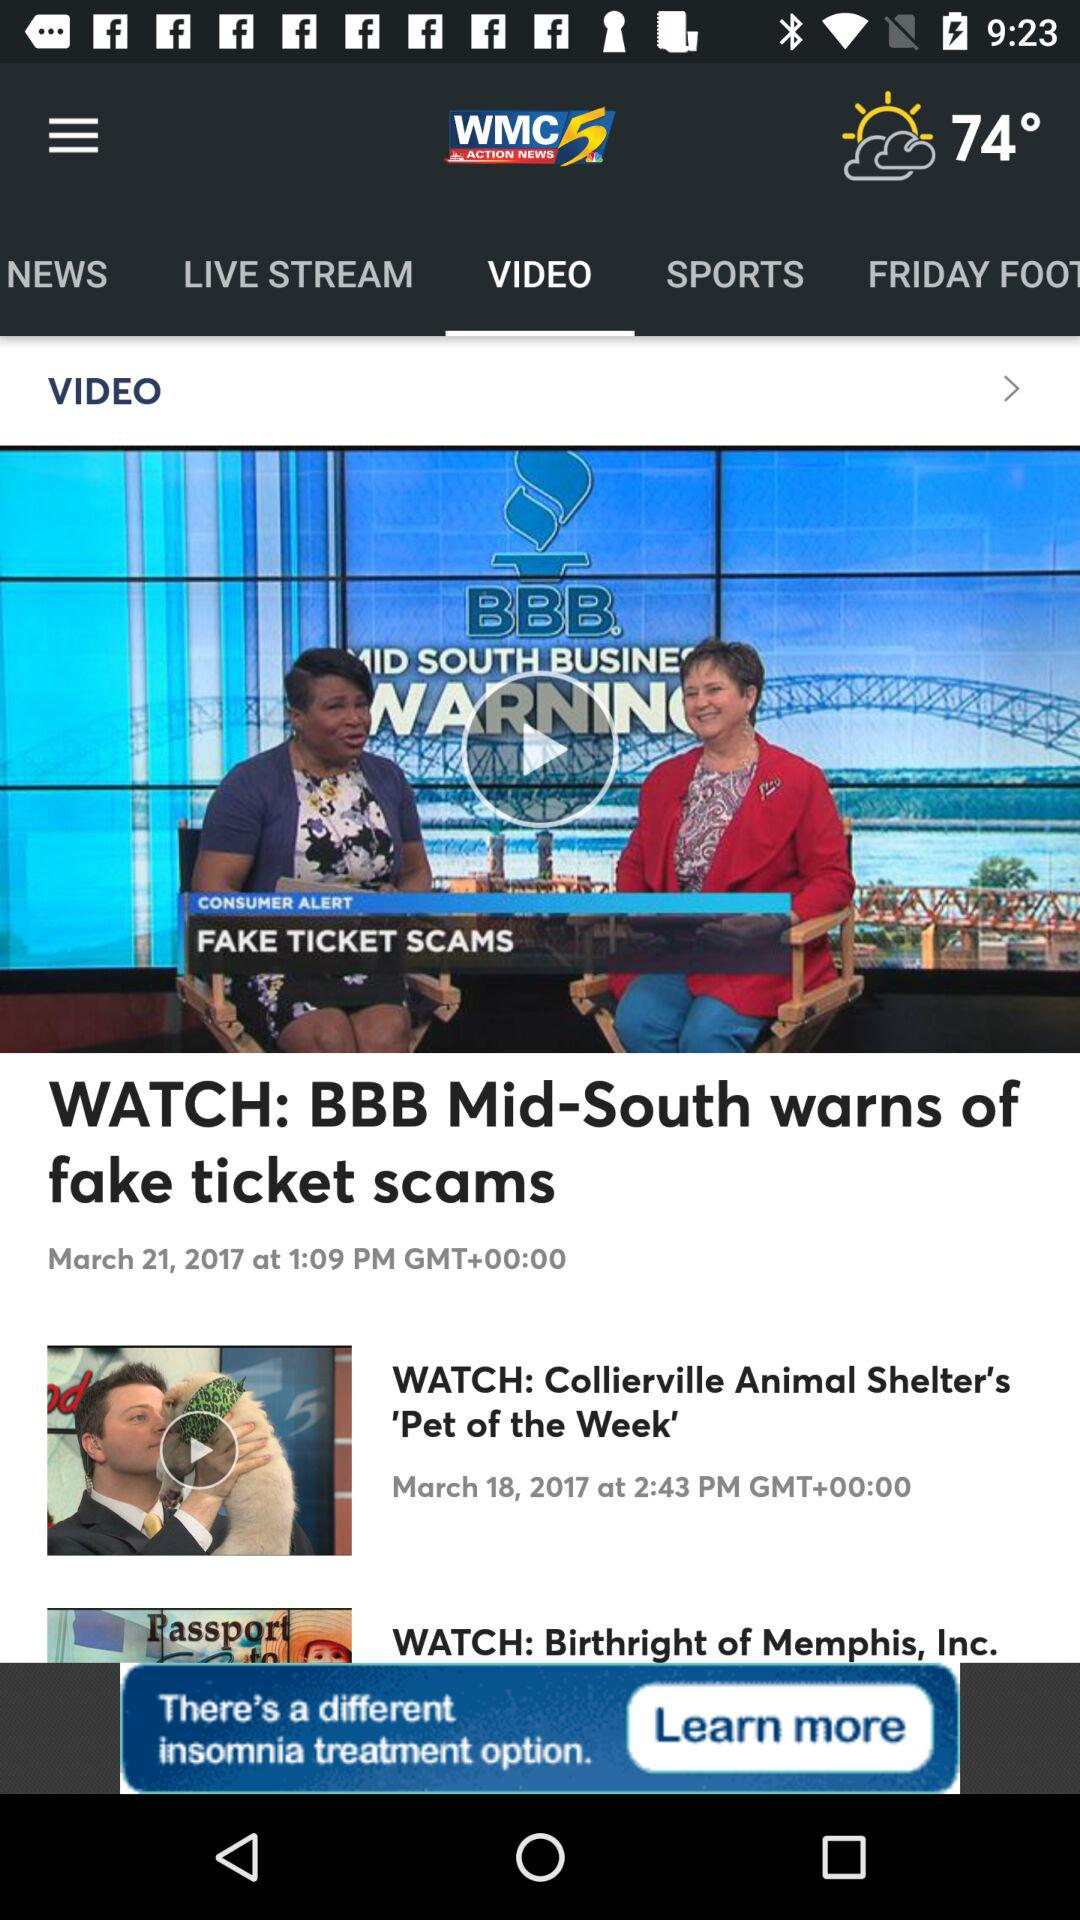What is the name of the application? The name of the application is "WMC5". 